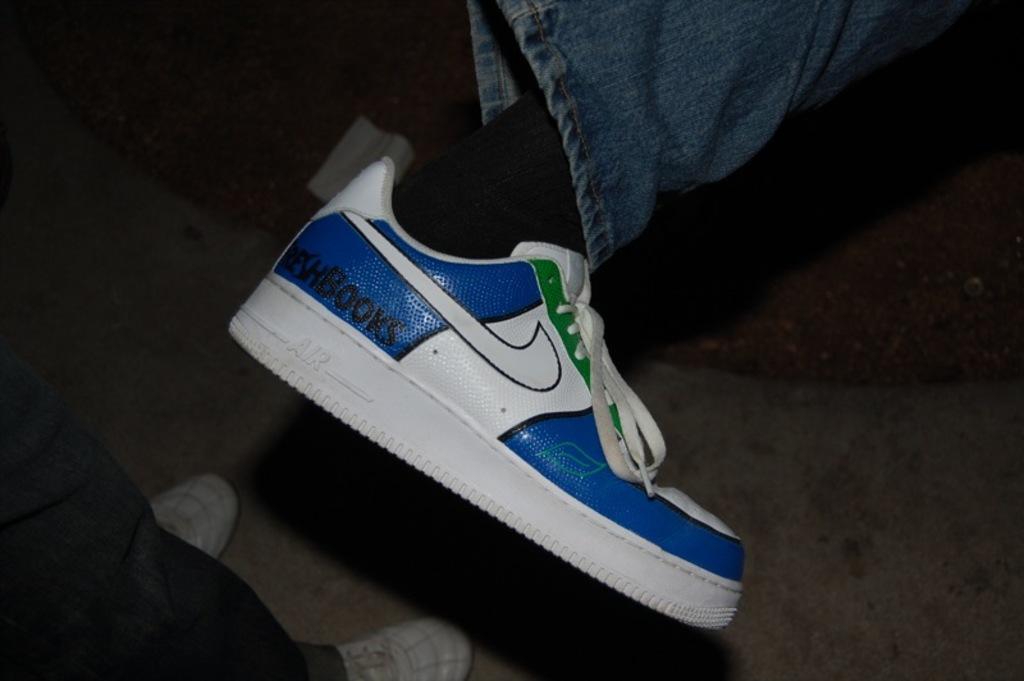Can you describe this image briefly? In this picture we can see legs of two persons, we can see jeans and shoes in the front, there is a dark background. 